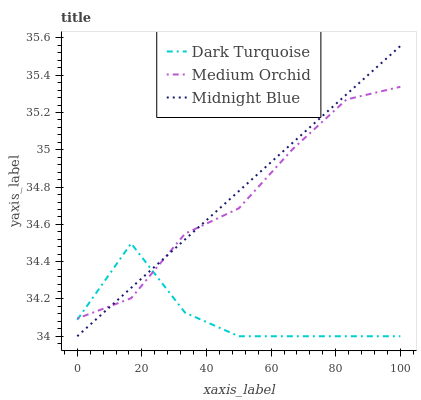Does Dark Turquoise have the minimum area under the curve?
Answer yes or no. Yes. Does Midnight Blue have the maximum area under the curve?
Answer yes or no. Yes. Does Medium Orchid have the minimum area under the curve?
Answer yes or no. No. Does Medium Orchid have the maximum area under the curve?
Answer yes or no. No. Is Midnight Blue the smoothest?
Answer yes or no. Yes. Is Dark Turquoise the roughest?
Answer yes or no. Yes. Is Medium Orchid the smoothest?
Answer yes or no. No. Is Medium Orchid the roughest?
Answer yes or no. No. Does Dark Turquoise have the lowest value?
Answer yes or no. Yes. Does Medium Orchid have the lowest value?
Answer yes or no. No. Does Midnight Blue have the highest value?
Answer yes or no. Yes. Does Medium Orchid have the highest value?
Answer yes or no. No. Does Medium Orchid intersect Dark Turquoise?
Answer yes or no. Yes. Is Medium Orchid less than Dark Turquoise?
Answer yes or no. No. Is Medium Orchid greater than Dark Turquoise?
Answer yes or no. No. 